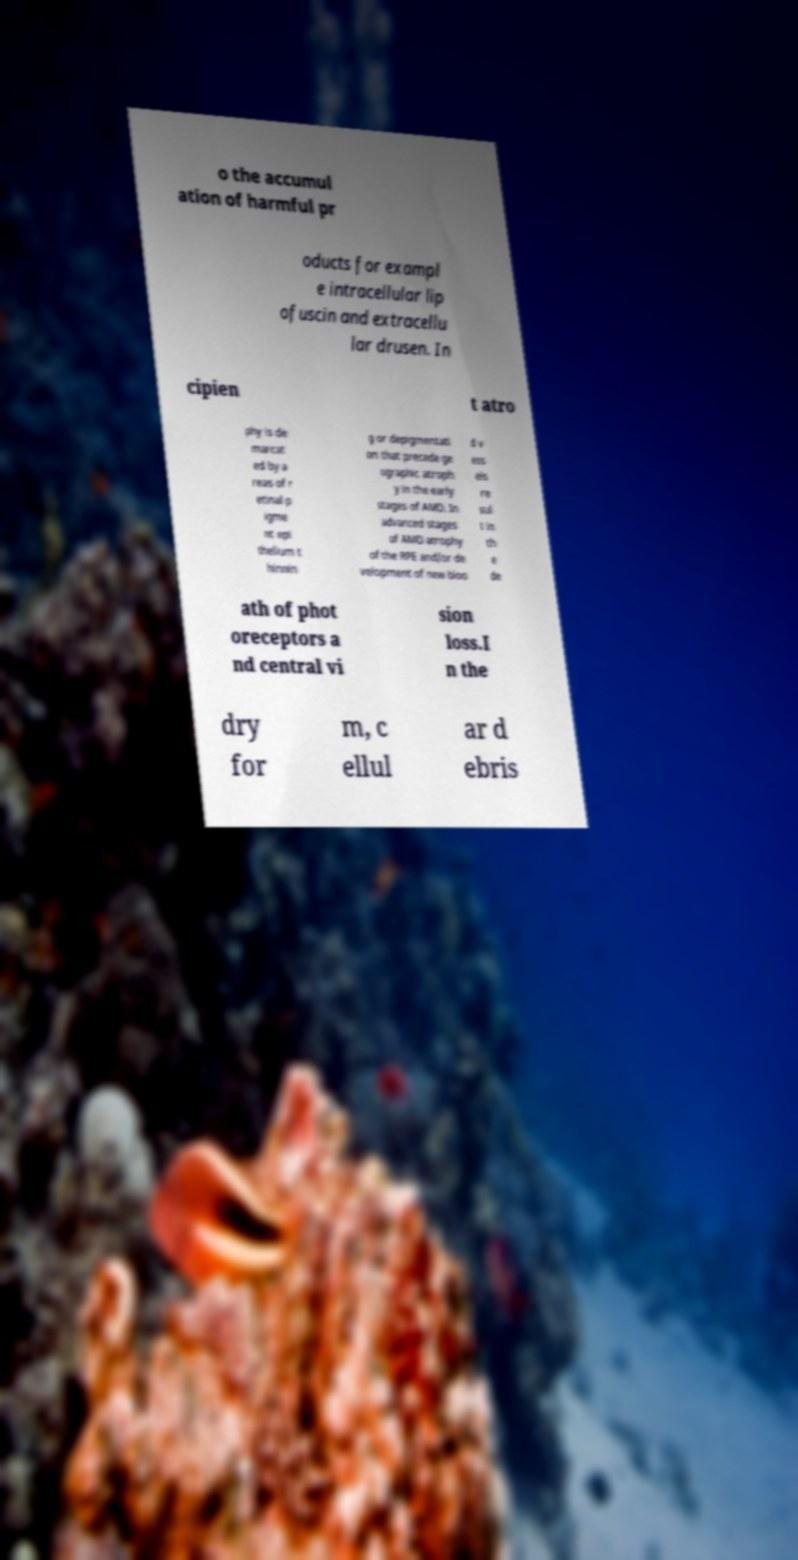I need the written content from this picture converted into text. Can you do that? o the accumul ation of harmful pr oducts for exampl e intracellular lip ofuscin and extracellu lar drusen. In cipien t atro phy is de marcat ed by a reas of r etinal p igme nt epi thelium t hinnin g or depigmentati on that precede ge ographic atroph y in the early stages of AMD. In advanced stages of AMD atrophy of the RPE and/or de velopment of new bloo d v ess els re sul t in th e de ath of phot oreceptors a nd central vi sion loss.I n the dry for m, c ellul ar d ebris 